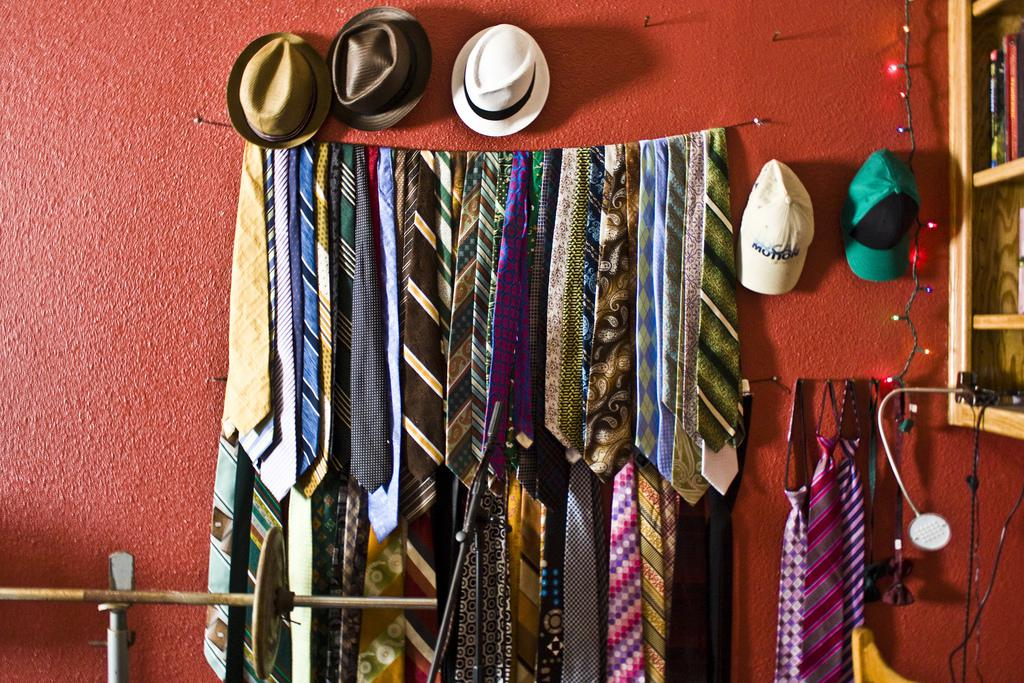Question: what color is the wall?
Choices:
A. Yellow.
B. Red.
C. White.
D. Blue.
Answer with the letter. Answer: B Question: what type of lights are hanging up?
Choices:
A. Traffic Lights.
B. Christmas lights.
C. Studio lights.
D. Neon lights.
Answer with the letter. Answer: B Question: who is in the room?
Choices:
A. No one.
B. Robert.
C. Sally.
D. Uncle Eddie.
Answer with the letter. Answer: A Question: why are the ties hanging?
Choices:
A. For organization.
B. To keep them out of the children's reach.
C. To keep them dry.
D. For display.
Answer with the letter. Answer: A Question: what style of hats are there?
Choices:
A. Beanie and sombrero.
B. Beret and flat cap.
C. Fedora and baseball.
D. Top hat and cowboy hat.
Answer with the letter. Answer: C Question: where is the photo taken?
Choices:
A. The bed.
B. A chair.
C. The back room.
D. A closet.
Answer with the letter. Answer: D Question: where are the empty nails?
Choices:
A. On the wall.
B. On the celing.
C. Sticking out the wall.
D. On the floor.
Answer with the letter. Answer: C Question: how many caps hang on the wall?
Choices:
A. Three.
B. Five.
C. Seven.
D. Two.
Answer with the letter. Answer: D Question: what hangs on a red wall?
Choices:
A. Ties, baseball caps and fedoras.
B. Pictures.
C. Clocks.
D. Deer mounts.
Answer with the letter. Answer: A Question: what is in the cabinet?
Choices:
A. Records.
B. Tapes.
C. Books.
D. Medical records.
Answer with the letter. Answer: C Question: what is the color of one of the fedoras?
Choices:
A. Black.
B. White.
C. Grey.
D. Green.
Answer with the letter. Answer: B Question: what is the status of the workout bench?
Choices:
A. Rusted out.
B. Not functional.
C. Unused.
D. Sweaty.
Answer with the letter. Answer: A Question: how much of the wooden shelf is empty?
Choices:
A. All of it.
B. The side.
C. Part.
D. The center.
Answer with the letter. Answer: C Question: how many hats are hanging on the red wall?
Choices:
A. Five.
B. Six.
C. Seven.
D. Eight.
Answer with the letter. Answer: A 